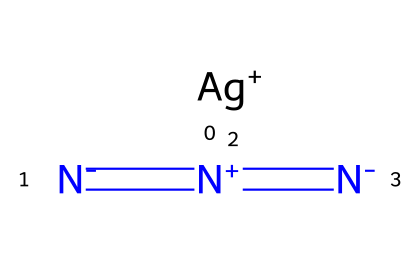What is the molecular formula of silver azide? The molecular formula can be determined from the elements present; silver (Ag), nitrogen (N), with the nitrogen atoms represented by three azide groups. The formula combines one silver atom with three nitrogen atoms.
Answer: AgN3 How many nitrogen atoms are in silver azide? The SMILES representation shows three nitrogen atoms, indicated by the structure where three nitrogen atoms are bonded in a linear arrangement.
Answer: 3 What type of compound is silver azide? Silver azide is classified as an azide compound, which typically contains the azide group (-N3) in its structure.
Answer: azide What charge does the silver ion carry in silver azide? The “Ag+” in the SMILES indicates that the silver ion has a positive charge.
Answer: +1 Given its structure, is silver azide light-sensitive? Silver azide contains bonds sensitive to light; compounds with azide groups are known to decompose or undergo reactions when exposed to light.
Answer: yes What characteristic distinguishes azide compounds like silver azide? Azide compounds are distinguished by the presence of the -N3 group. In silver azide, this characteristic functional group is essential for its properties.
Answer: -N3 group 